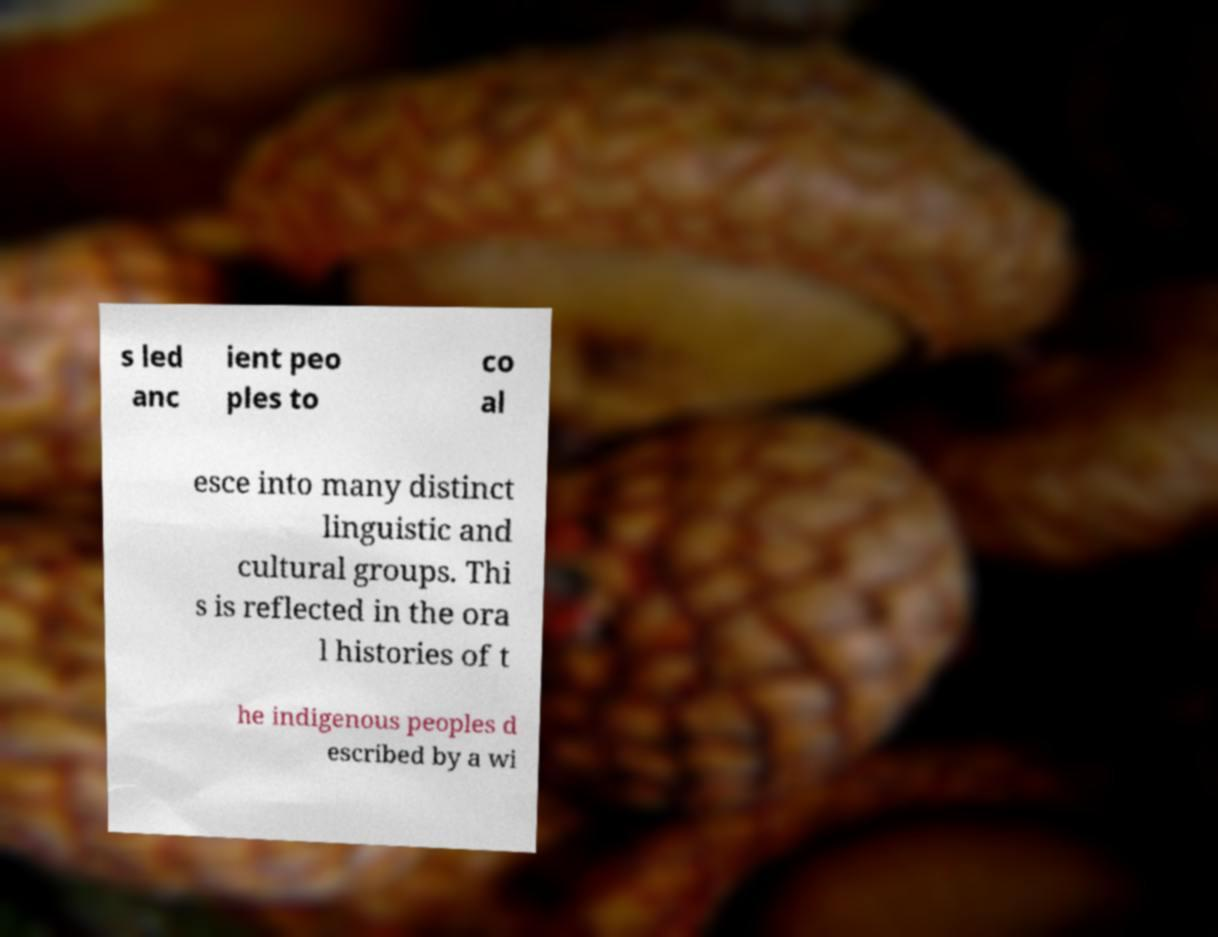Please read and relay the text visible in this image. What does it say? s led anc ient peo ples to co al esce into many distinct linguistic and cultural groups. Thi s is reflected in the ora l histories of t he indigenous peoples d escribed by a wi 